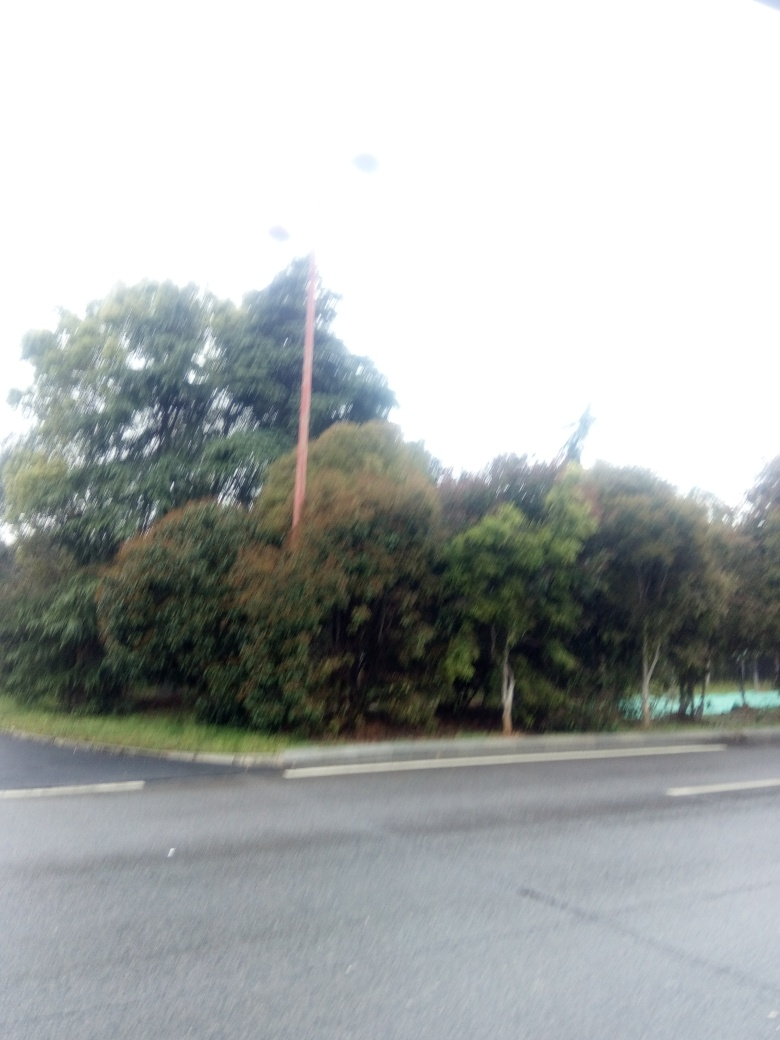How could this image be improved through editing? To improve the image, one could start by decreasing the exposure to recover some details lost in the brightness. Adjusting the contrast and saturation might also help to enhance the visibility of the elements within the picture, such as trees and the road. 